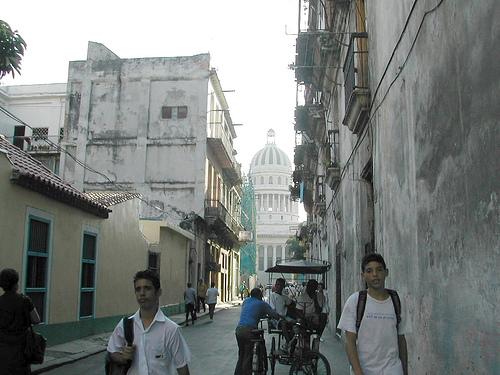Are there mountains in the background?
Short answer required. No. Is it a windy day?
Give a very brief answer. No. Is this image in black and white?
Write a very short answer. No. Is this photo blurry?
Write a very short answer. No. How many people are in the carriage?
Be succinct. 2. What building is in the background?
Answer briefly. Church. How many people are there?
Short answer required. 9. Is it dry outside?
Short answer required. Yes. Are these people smiling?
Write a very short answer. No. 